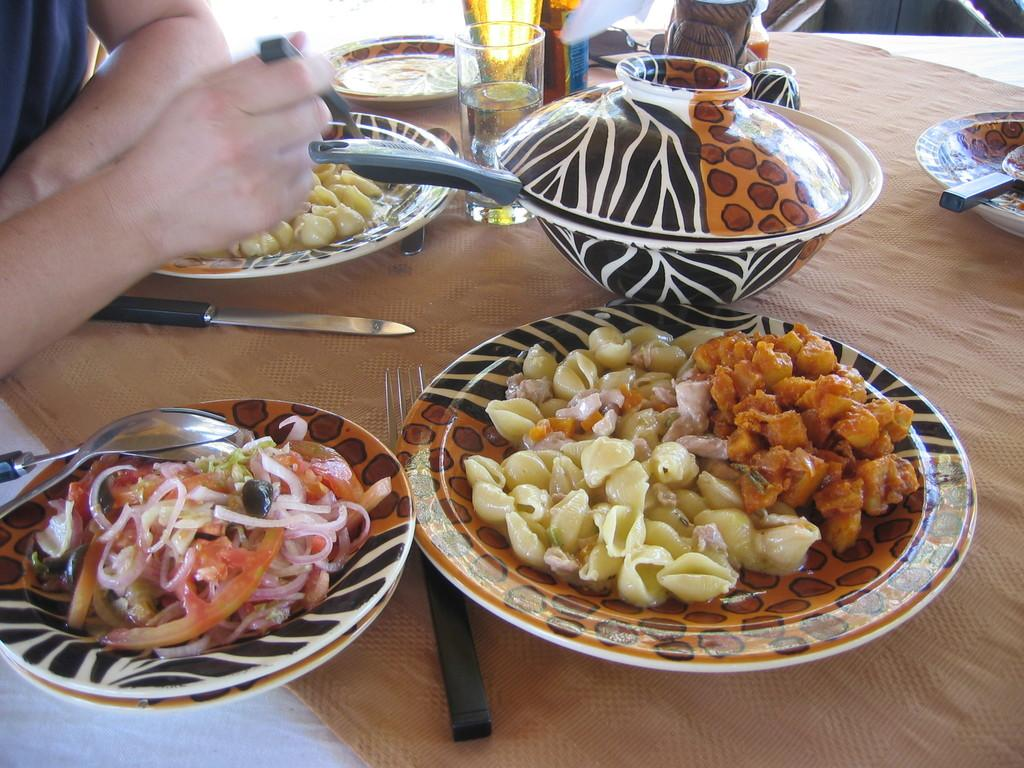What type of objects can be seen on the table in the image? There are plates with food items, forks, knives, spoons, bowls, and glasses on the table in the image. What might be used for eating the food items on the plates? Forks, knives, and spoons can be used for eating the food items on the plates. What type of container is present for holding liquids? Glasses are present for holding liquids. Can you describe the person beside the table in the image? The provided facts do not mention any details about the person beside the table. What type of wool can be seen in the image? There is no wool present in the image. Can you describe the bait used for fishing in the image? There is no fishing or bait present in the image. 